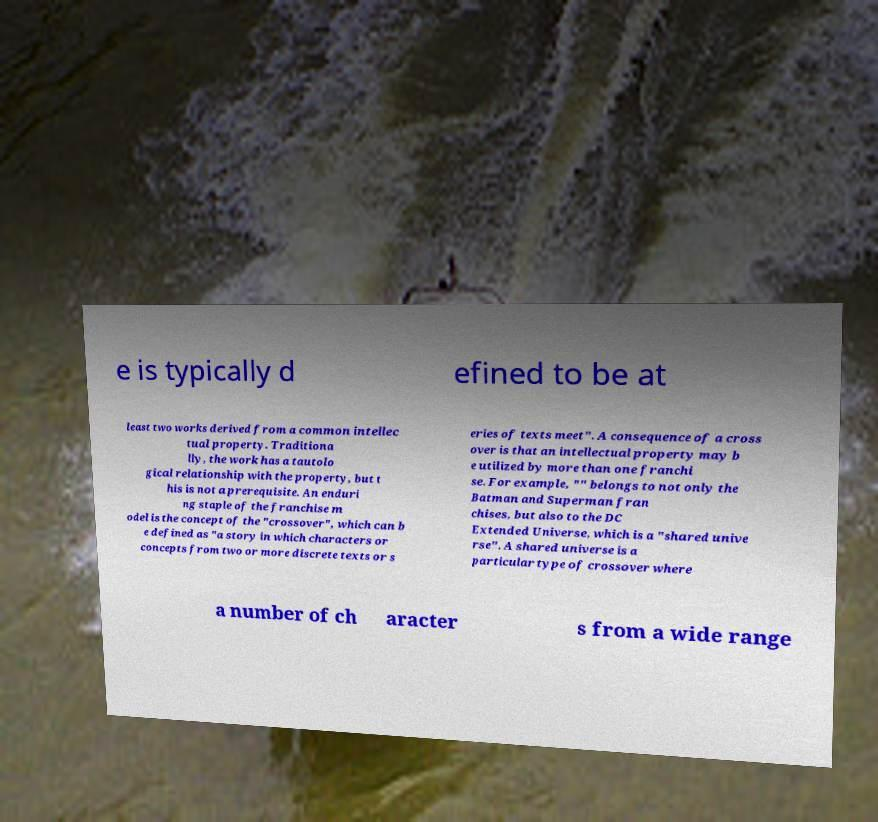Can you read and provide the text displayed in the image?This photo seems to have some interesting text. Can you extract and type it out for me? e is typically d efined to be at least two works derived from a common intellec tual property. Traditiona lly, the work has a tautolo gical relationship with the property, but t his is not a prerequisite. An enduri ng staple of the franchise m odel is the concept of the "crossover", which can b e defined as "a story in which characters or concepts from two or more discrete texts or s eries of texts meet". A consequence of a cross over is that an intellectual property may b e utilized by more than one franchi se. For example, "" belongs to not only the Batman and Superman fran chises, but also to the DC Extended Universe, which is a "shared unive rse". A shared universe is a particular type of crossover where a number of ch aracter s from a wide range 